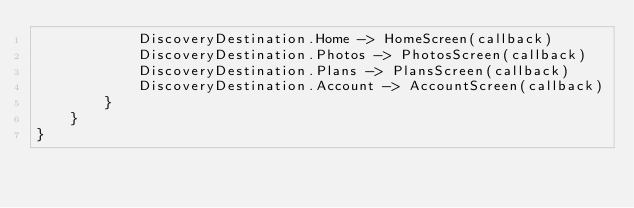<code> <loc_0><loc_0><loc_500><loc_500><_Kotlin_>            DiscoveryDestination.Home -> HomeScreen(callback)
            DiscoveryDestination.Photos -> PhotosScreen(callback)
            DiscoveryDestination.Plans -> PlansScreen(callback)
            DiscoveryDestination.Account -> AccountScreen(callback)
        }
    }
}</code> 